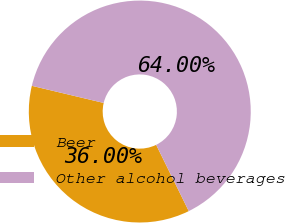Convert chart. <chart><loc_0><loc_0><loc_500><loc_500><pie_chart><fcel>Beer<fcel>Other alcohol beverages<nl><fcel>36.0%<fcel>64.0%<nl></chart> 